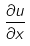Convert formula to latex. <formula><loc_0><loc_0><loc_500><loc_500>\frac { \partial u } { \partial x }</formula> 